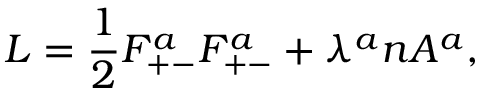Convert formula to latex. <formula><loc_0><loc_0><loc_500><loc_500>L = { \frac { 1 } { 2 } } F _ { + - } ^ { a } F _ { + - } ^ { a } + \lambda ^ { a } n A ^ { a } ,</formula> 